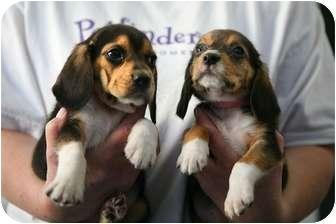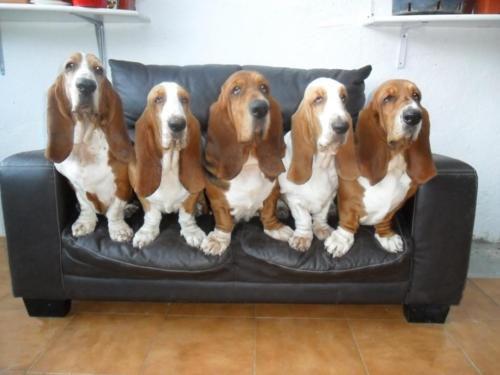The first image is the image on the left, the second image is the image on the right. For the images shown, is this caption "At least one dog is resting on a couch." true? Answer yes or no. Yes. The first image is the image on the left, the second image is the image on the right. For the images displayed, is the sentence "Four long eared beagles are looking over a wooden barrier." factually correct? Answer yes or no. No. 